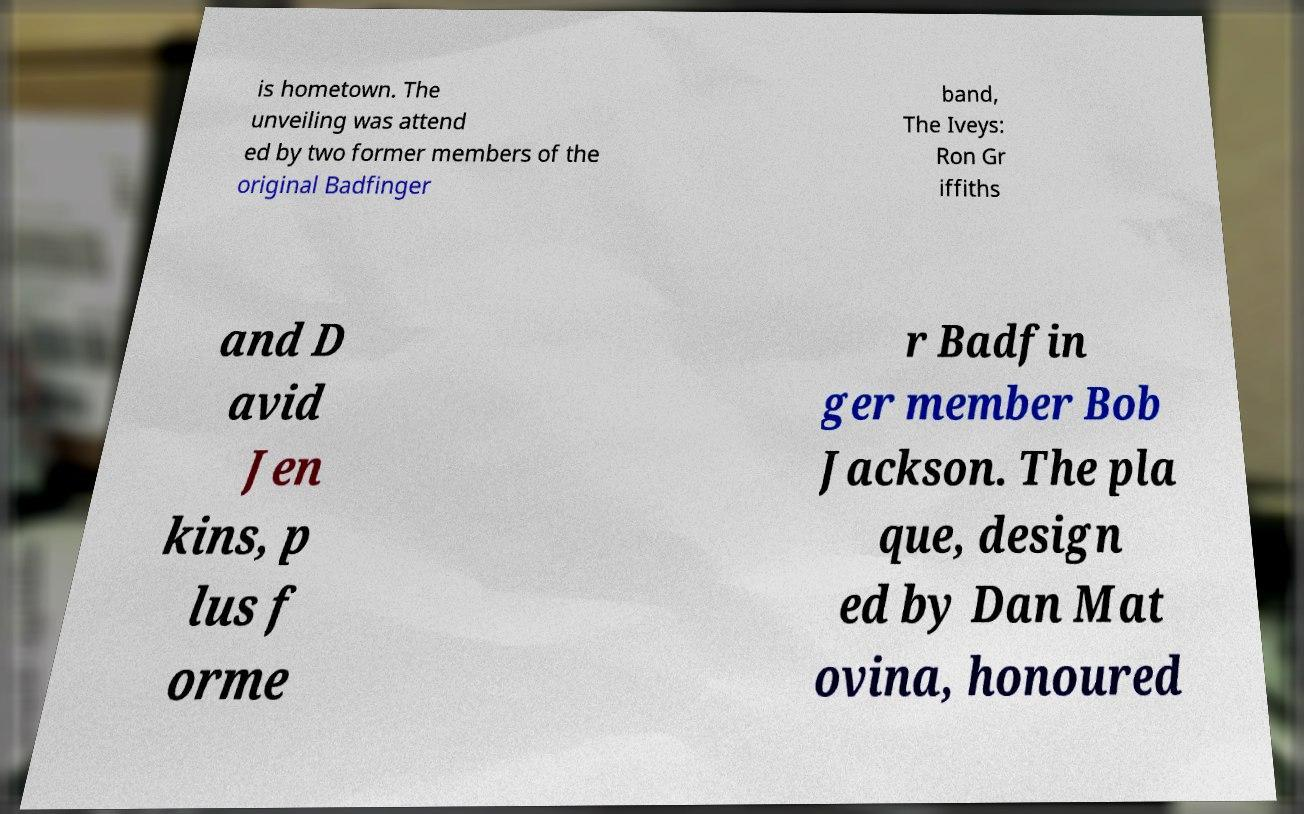Can you accurately transcribe the text from the provided image for me? is hometown. The unveiling was attend ed by two former members of the original Badfinger band, The Iveys: Ron Gr iffiths and D avid Jen kins, p lus f orme r Badfin ger member Bob Jackson. The pla que, design ed by Dan Mat ovina, honoured 